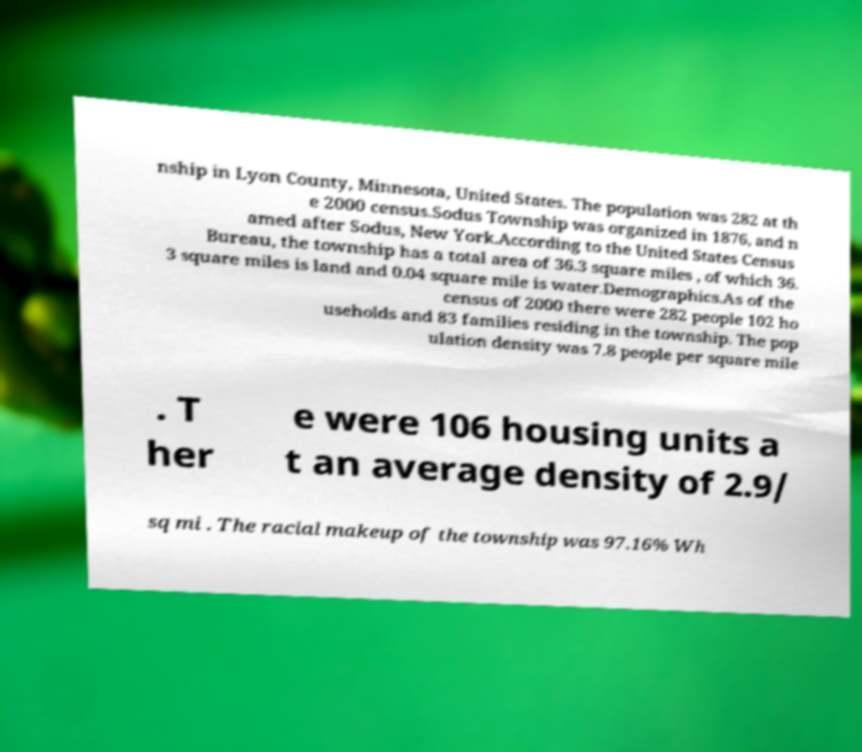Can you accurately transcribe the text from the provided image for me? nship in Lyon County, Minnesota, United States. The population was 282 at th e 2000 census.Sodus Township was organized in 1876, and n amed after Sodus, New York.According to the United States Census Bureau, the township has a total area of 36.3 square miles , of which 36. 3 square miles is land and 0.04 square mile is water.Demographics.As of the census of 2000 there were 282 people 102 ho useholds and 83 families residing in the township. The pop ulation density was 7.8 people per square mile . T her e were 106 housing units a t an average density of 2.9/ sq mi . The racial makeup of the township was 97.16% Wh 